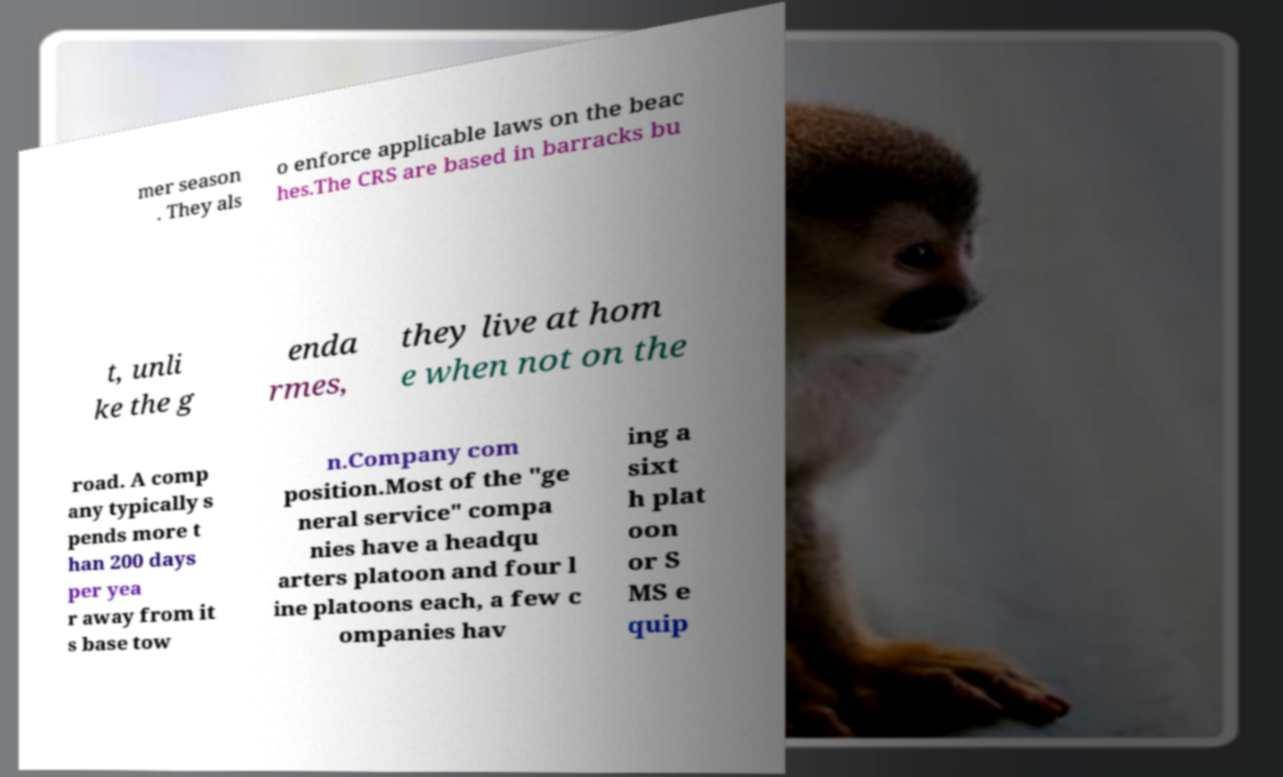Could you extract and type out the text from this image? mer season . They als o enforce applicable laws on the beac hes.The CRS are based in barracks bu t, unli ke the g enda rmes, they live at hom e when not on the road. A comp any typically s pends more t han 200 days per yea r away from it s base tow n.Company com position.Most of the "ge neral service" compa nies have a headqu arters platoon and four l ine platoons each, a few c ompanies hav ing a sixt h plat oon or S MS e quip 